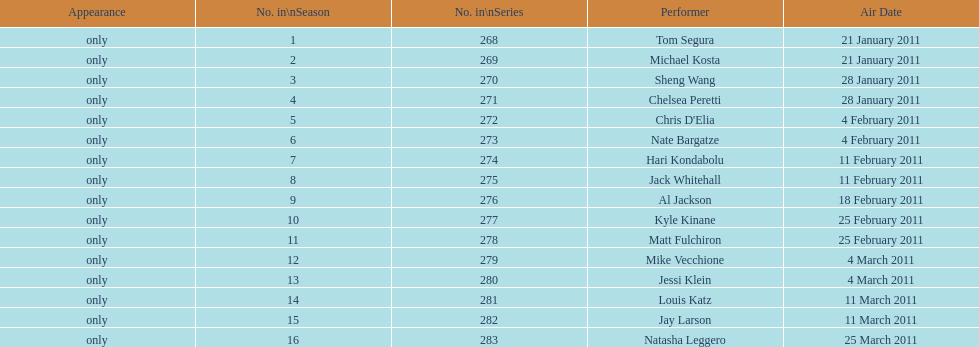How many weeks did season 15 of comedy central presents span? 9. 